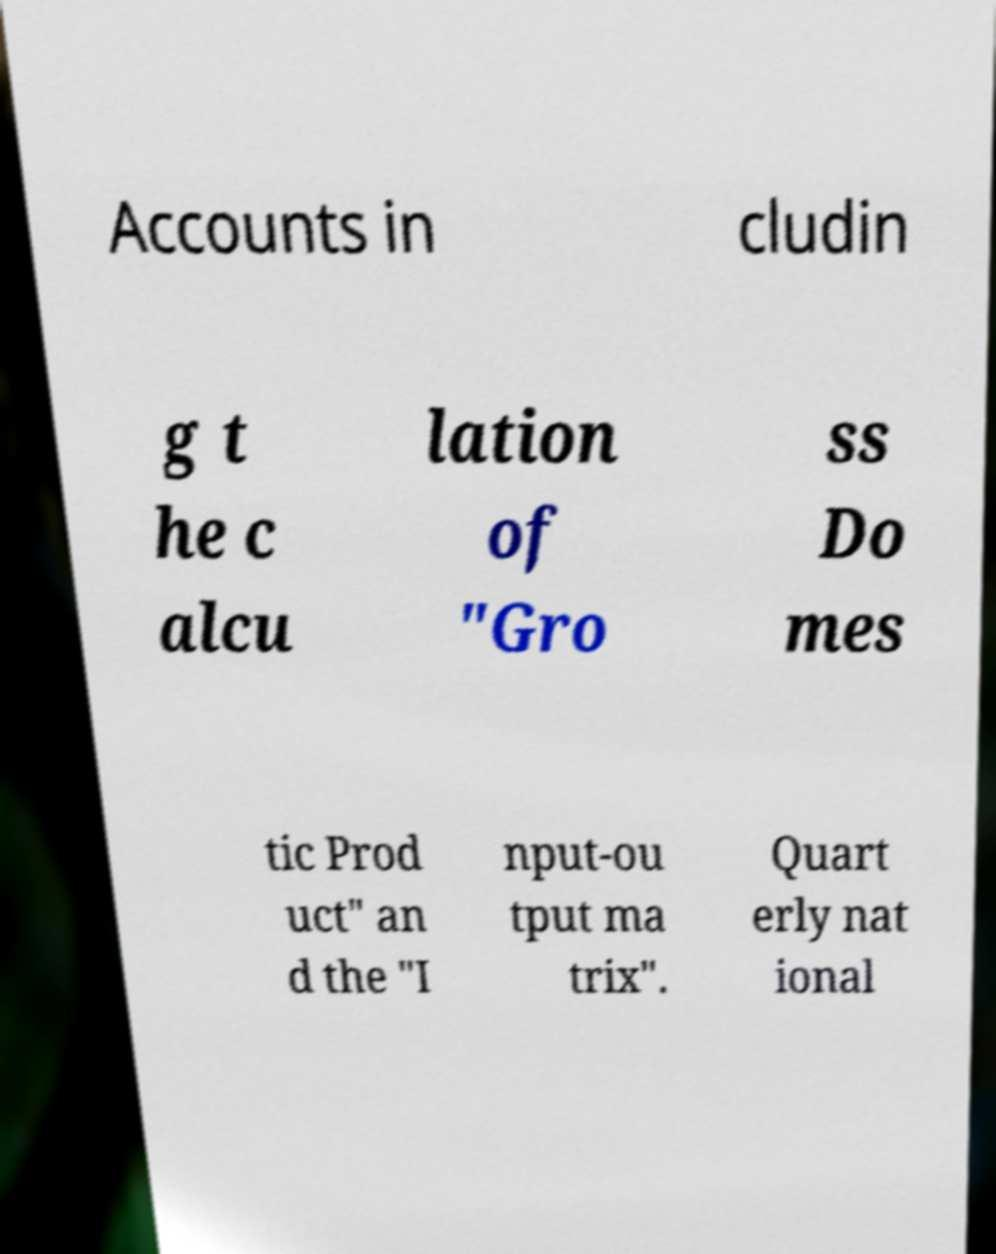There's text embedded in this image that I need extracted. Can you transcribe it verbatim? Accounts in cludin g t he c alcu lation of "Gro ss Do mes tic Prod uct" an d the "I nput-ou tput ma trix". Quart erly nat ional 